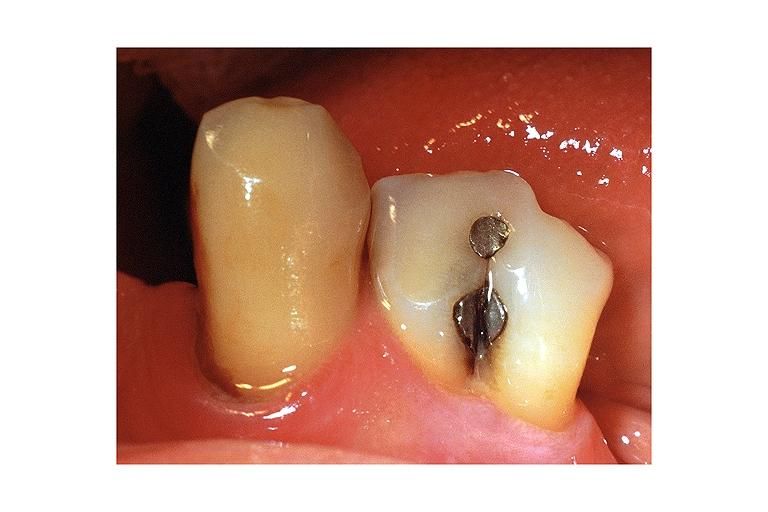what is present?
Answer the question using a single word or phrase. Oral 